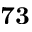<formula> <loc_0><loc_0><loc_500><loc_500>7 3</formula> 